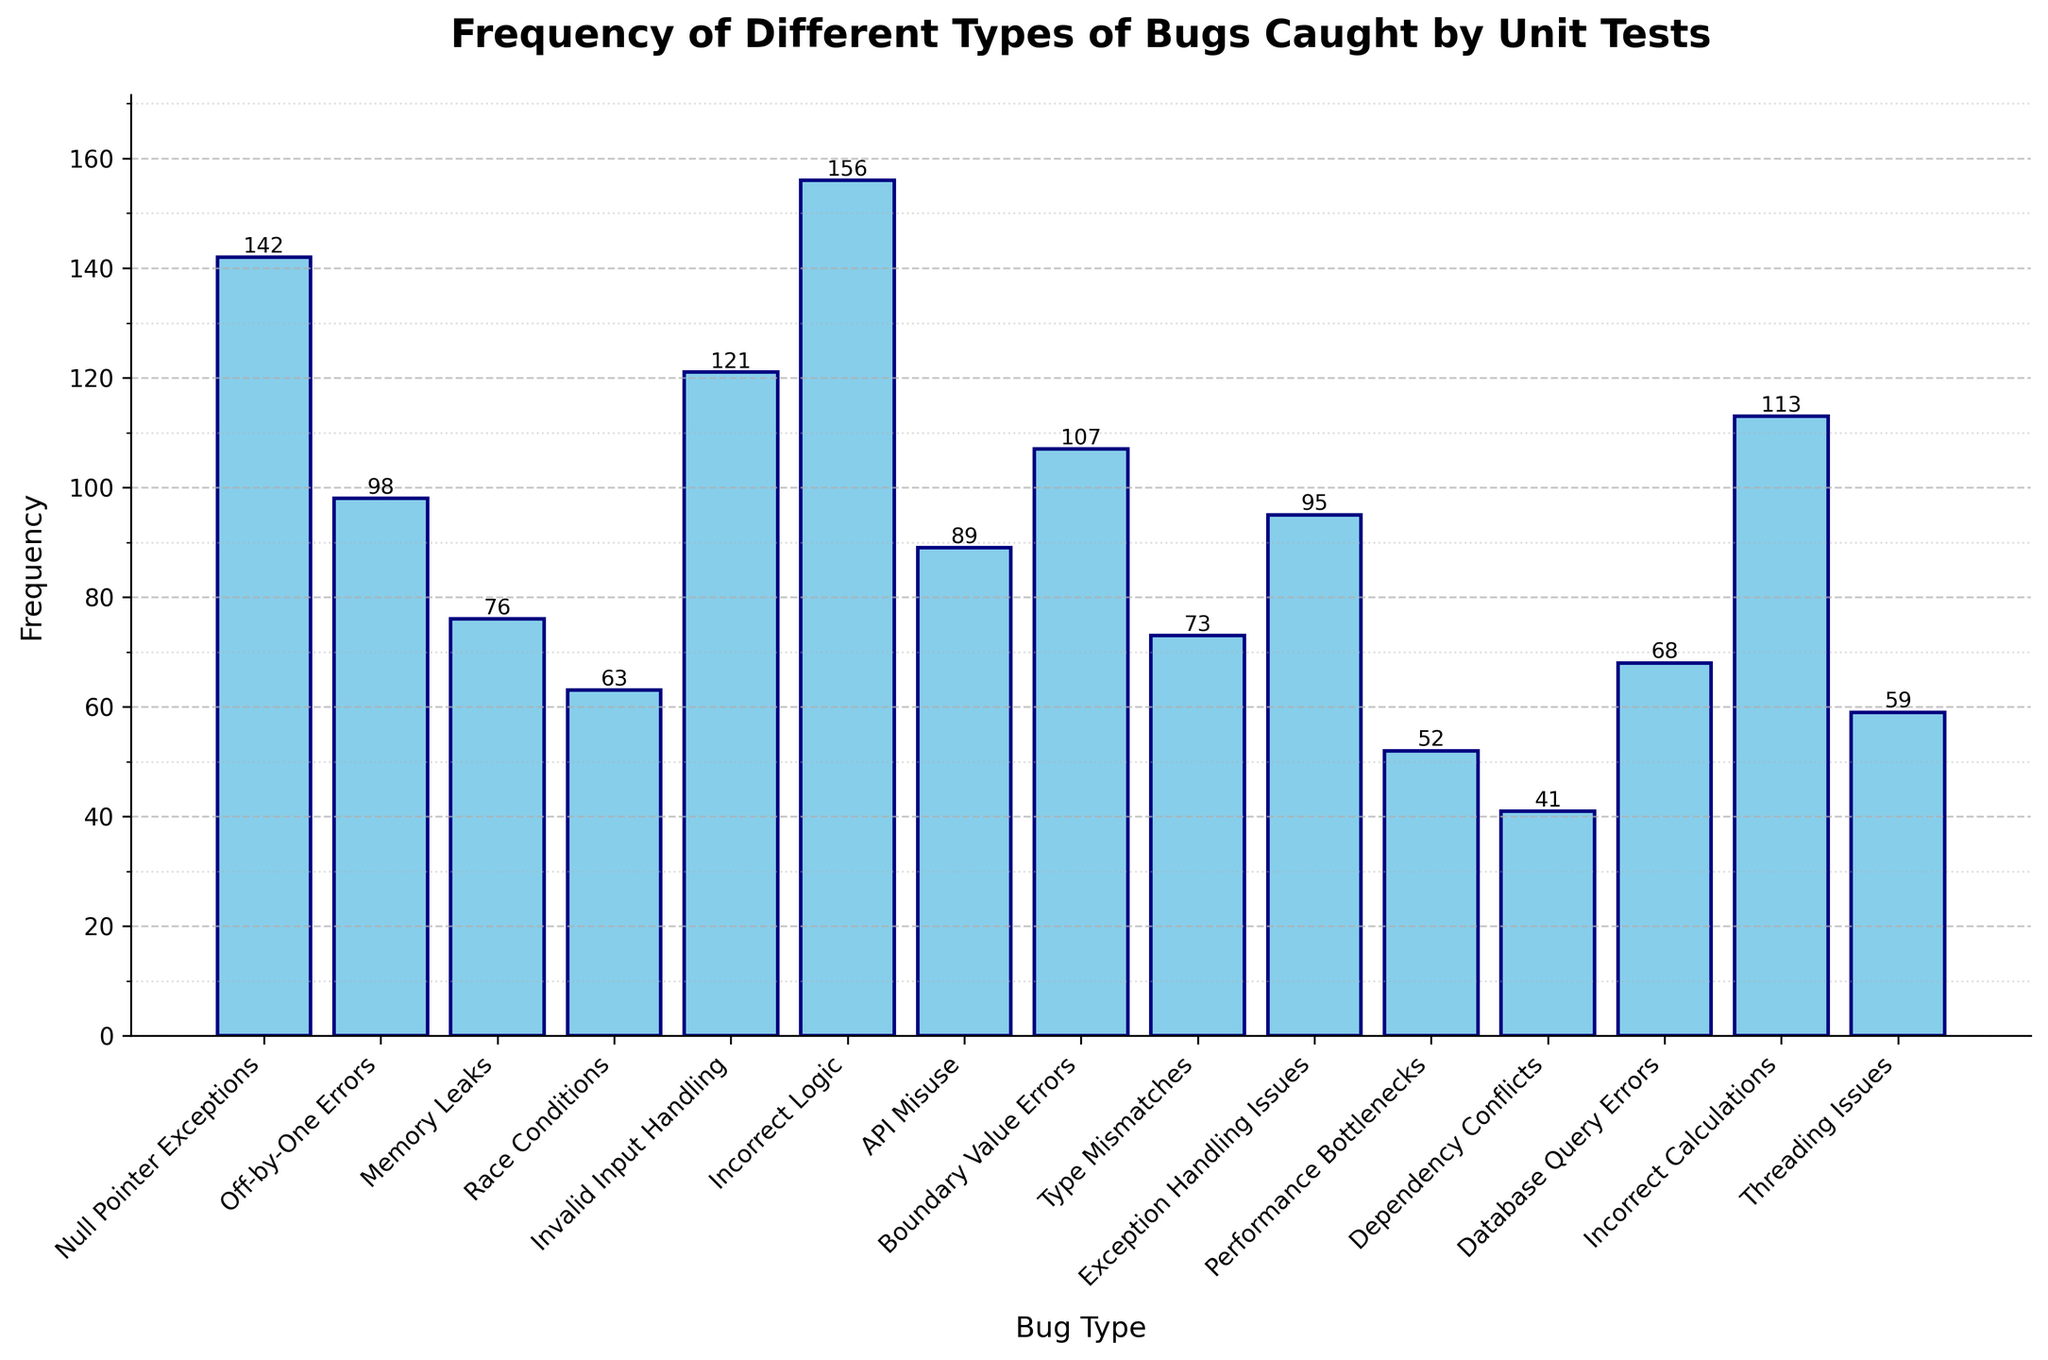Which bug type has the highest frequency? To find the bug type with the highest frequency, look for the bar that extends the highest on the y-axis. The bar for "Incorrect Logic" is the tallest, indicating it has the highest frequency.
Answer: Incorrect Logic Which bug type has the lowest frequency? To determine the bug type with the lowest frequency, look for the shortest bar on the chart. The bar for "Dependency Conflicts" is the shortest, meaning it has the lowest frequency.
Answer: Dependency Conflicts Compare the frequencies of Null Pointer Exceptions and Invalid Input Handling. Which is higher and by how much? Find the bars representing Null Pointer Exceptions and Invalid Input Handling. Null Pointer Exceptions has a frequency of 142, while Invalid Input Handling has 121. Subtracting these, Null Pointer Exceptions is higher by 21.
Answer: Null Pointer Exceptions by 21 What is the total frequency of all bug types with frequencies above 100? Identify and sum the frequencies of bars exceeding 100: Null Pointer Exceptions (142), Invalid Input Handling (121), Incorrect Logic (156), Boundary Value Errors (107), and Incorrect Calculations (113). Summing these: 142 + 121 + 156 + 107 + 113 = 639.
Answer: 639 Which bug types have a frequency between 50 and 75? Examine the bars and their frequencies: Memory Leaks (76 is excluded), Race Conditions (63), Type Mismatches (73), Performance Bottlenecks (52), Dependency Conflicts (41 is excluded), Database Query Errors (68), Threading Issues (59). These fall within the specified range.
Answer: Race Conditions, Type Mismatches, Performance Bottlenecks, Database Query Errors, Threading Issues How many bug types have a frequency higher than 100? Count the number of bars with a height indicating a frequency greater than 100: Null Pointer Exceptions, Invalid Input Handling, Incorrect Logic, Boundary Value Errors, and Incorrect Calculations. There are 5 such bug types.
Answer: 5 Which pairs of bug types have the same frequency? Scan the chart for pairs of bars of equal height. None of the bars have the same height, indicating no pairs with identical frequencies.
Answer: None What is the average frequency of all bug types? Sum all frequencies: 142 + 98 + 76 + 63 + 121 + 156 + 89 + 107 + 73 + 95 + 52 + 41 + 68 + 113 + 59 = 1253. Divide by the number of bug types, 15: 1253 / 15 ≈ 83.53.
Answer: ~83.53 